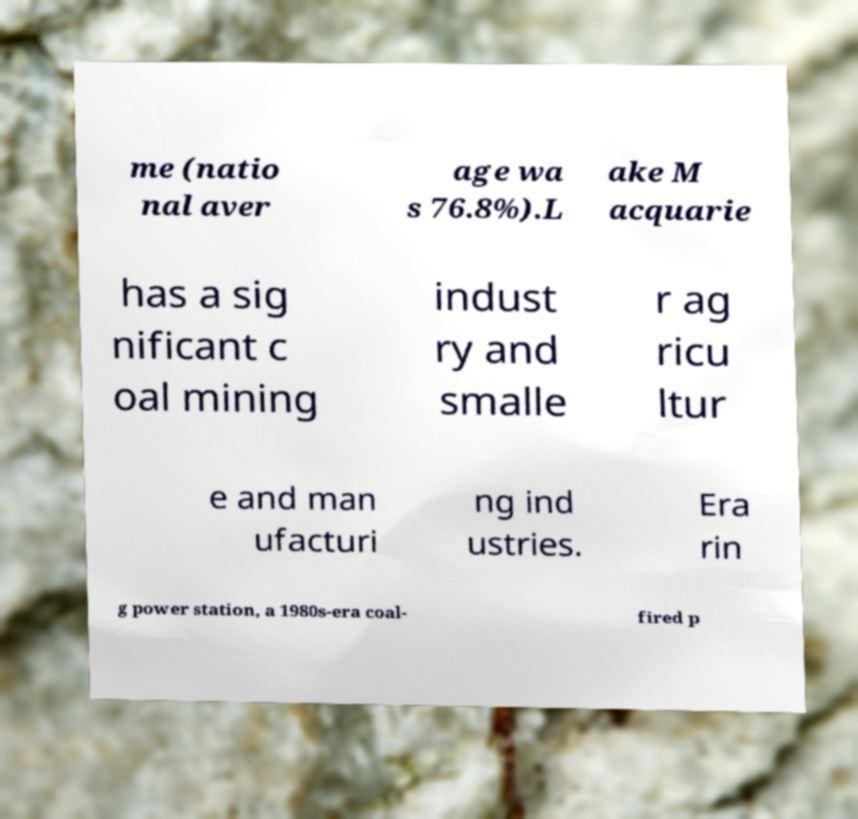Could you extract and type out the text from this image? me (natio nal aver age wa s 76.8%).L ake M acquarie has a sig nificant c oal mining indust ry and smalle r ag ricu ltur e and man ufacturi ng ind ustries. Era rin g power station, a 1980s-era coal- fired p 